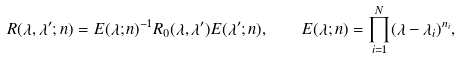Convert formula to latex. <formula><loc_0><loc_0><loc_500><loc_500>R ( \lambda , \lambda ^ { \prime } ; n ) = E ( \lambda ; n ) ^ { - 1 } R _ { 0 } ( \lambda , \lambda ^ { \prime } ) E ( \lambda ^ { \prime } ; n ) , \quad E ( \lambda ; n ) = \prod _ { i = 1 } ^ { N } ( \lambda - \lambda _ { i } ) ^ { n _ { i } } ,</formula> 